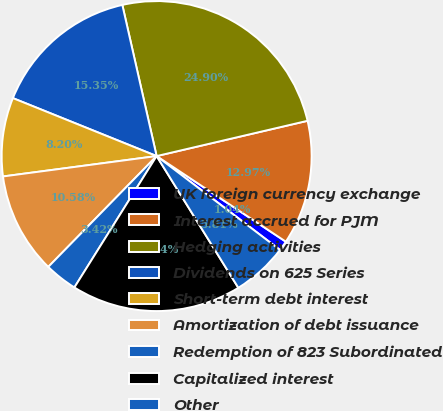Convert chart to OTSL. <chart><loc_0><loc_0><loc_500><loc_500><pie_chart><fcel>UK foreign currency exchange<fcel>Interest accrued for PJM<fcel>Hedging activities<fcel>Dividends on 625 Series<fcel>Short-term debt interest<fcel>Amortization of debt issuance<fcel>Redemption of 823 Subordinated<fcel>Capitalized interest<fcel>Other<nl><fcel>1.04%<fcel>12.97%<fcel>24.9%<fcel>15.35%<fcel>8.2%<fcel>10.58%<fcel>3.42%<fcel>17.74%<fcel>5.81%<nl></chart> 